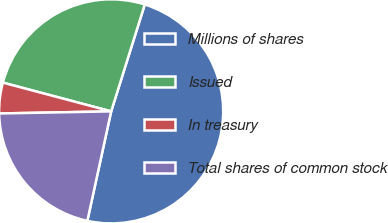Convert chart. <chart><loc_0><loc_0><loc_500><loc_500><pie_chart><fcel>Millions of shares<fcel>Issued<fcel>In treasury<fcel>Total shares of common stock<nl><fcel>48.56%<fcel>25.72%<fcel>4.43%<fcel>21.29%<nl></chart> 